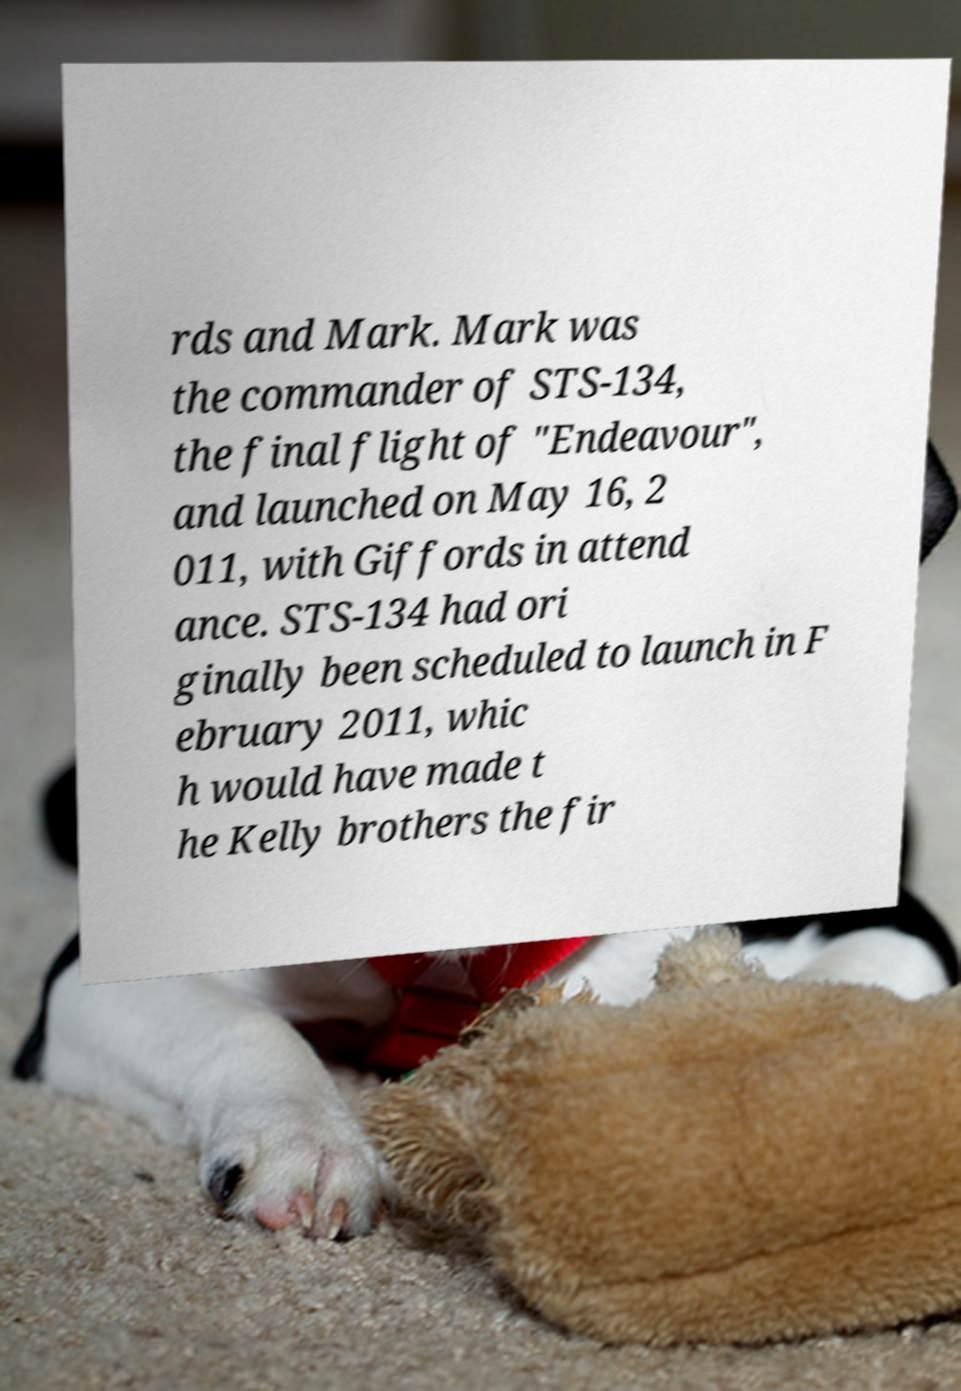Please read and relay the text visible in this image. What does it say? rds and Mark. Mark was the commander of STS-134, the final flight of "Endeavour", and launched on May 16, 2 011, with Giffords in attend ance. STS-134 had ori ginally been scheduled to launch in F ebruary 2011, whic h would have made t he Kelly brothers the fir 